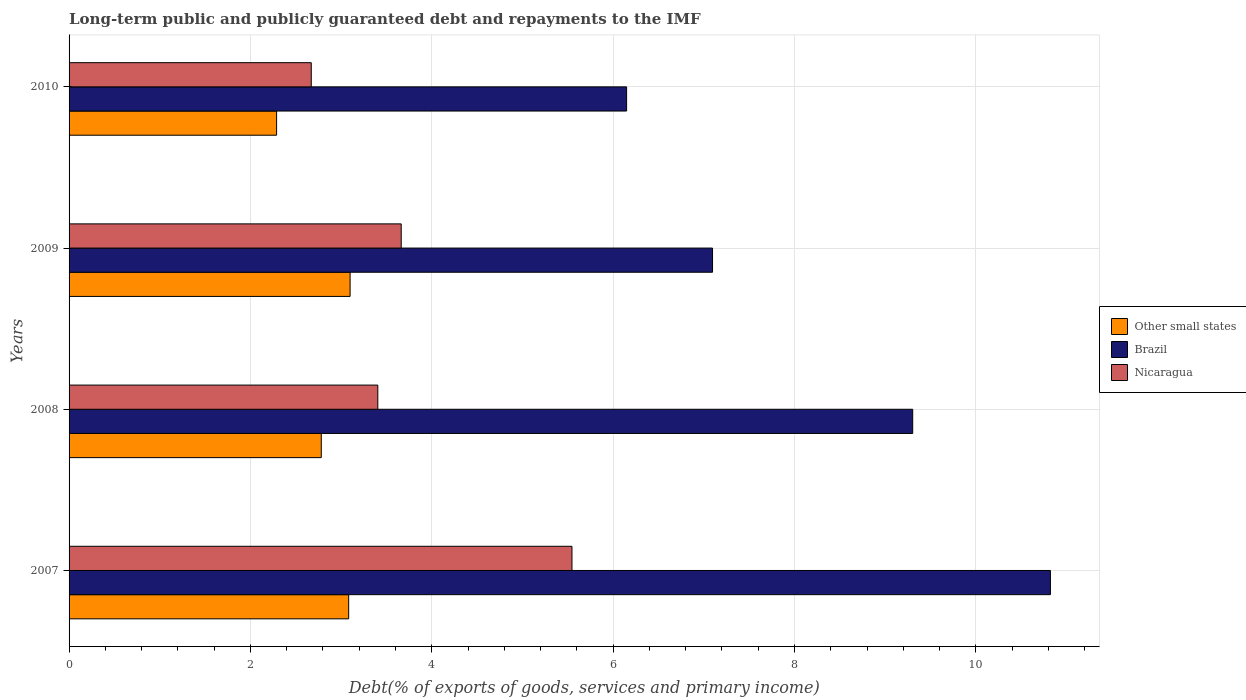How many different coloured bars are there?
Offer a very short reply. 3. How many groups of bars are there?
Offer a terse response. 4. Are the number of bars per tick equal to the number of legend labels?
Provide a succinct answer. Yes. How many bars are there on the 3rd tick from the top?
Keep it short and to the point. 3. How many bars are there on the 1st tick from the bottom?
Provide a short and direct response. 3. What is the label of the 4th group of bars from the top?
Provide a short and direct response. 2007. What is the debt and repayments in Nicaragua in 2010?
Provide a short and direct response. 2.67. Across all years, what is the maximum debt and repayments in Nicaragua?
Ensure brevity in your answer.  5.55. Across all years, what is the minimum debt and repayments in Nicaragua?
Offer a terse response. 2.67. In which year was the debt and repayments in Brazil minimum?
Your answer should be very brief. 2010. What is the total debt and repayments in Nicaragua in the graph?
Provide a short and direct response. 15.28. What is the difference between the debt and repayments in Brazil in 2007 and that in 2010?
Provide a succinct answer. 4.67. What is the difference between the debt and repayments in Nicaragua in 2010 and the debt and repayments in Brazil in 2008?
Make the answer very short. -6.63. What is the average debt and repayments in Other small states per year?
Provide a short and direct response. 2.81. In the year 2010, what is the difference between the debt and repayments in Other small states and debt and repayments in Brazil?
Your response must be concise. -3.86. In how many years, is the debt and repayments in Nicaragua greater than 5.2 %?
Ensure brevity in your answer.  1. What is the ratio of the debt and repayments in Other small states in 2007 to that in 2010?
Provide a short and direct response. 1.35. Is the debt and repayments in Nicaragua in 2008 less than that in 2010?
Provide a succinct answer. No. Is the difference between the debt and repayments in Other small states in 2009 and 2010 greater than the difference between the debt and repayments in Brazil in 2009 and 2010?
Make the answer very short. No. What is the difference between the highest and the second highest debt and repayments in Nicaragua?
Offer a terse response. 1.88. What is the difference between the highest and the lowest debt and repayments in Nicaragua?
Ensure brevity in your answer.  2.87. What does the 3rd bar from the top in 2007 represents?
Offer a terse response. Other small states. What does the 2nd bar from the bottom in 2010 represents?
Make the answer very short. Brazil. Is it the case that in every year, the sum of the debt and repayments in Other small states and debt and repayments in Nicaragua is greater than the debt and repayments in Brazil?
Your response must be concise. No. Are all the bars in the graph horizontal?
Your response must be concise. Yes. Does the graph contain any zero values?
Provide a short and direct response. No. Does the graph contain grids?
Your answer should be very brief. Yes. Where does the legend appear in the graph?
Keep it short and to the point. Center right. How many legend labels are there?
Ensure brevity in your answer.  3. What is the title of the graph?
Your response must be concise. Long-term public and publicly guaranteed debt and repayments to the IMF. Does "Burundi" appear as one of the legend labels in the graph?
Offer a very short reply. No. What is the label or title of the X-axis?
Offer a very short reply. Debt(% of exports of goods, services and primary income). What is the Debt(% of exports of goods, services and primary income) of Other small states in 2007?
Give a very brief answer. 3.08. What is the Debt(% of exports of goods, services and primary income) of Brazil in 2007?
Make the answer very short. 10.82. What is the Debt(% of exports of goods, services and primary income) in Nicaragua in 2007?
Your response must be concise. 5.55. What is the Debt(% of exports of goods, services and primary income) in Other small states in 2008?
Provide a succinct answer. 2.78. What is the Debt(% of exports of goods, services and primary income) of Brazil in 2008?
Offer a terse response. 9.3. What is the Debt(% of exports of goods, services and primary income) in Nicaragua in 2008?
Your answer should be very brief. 3.4. What is the Debt(% of exports of goods, services and primary income) of Other small states in 2009?
Make the answer very short. 3.1. What is the Debt(% of exports of goods, services and primary income) in Brazil in 2009?
Your answer should be compact. 7.1. What is the Debt(% of exports of goods, services and primary income) in Nicaragua in 2009?
Offer a very short reply. 3.66. What is the Debt(% of exports of goods, services and primary income) in Other small states in 2010?
Offer a very short reply. 2.29. What is the Debt(% of exports of goods, services and primary income) in Brazil in 2010?
Provide a short and direct response. 6.15. What is the Debt(% of exports of goods, services and primary income) in Nicaragua in 2010?
Provide a short and direct response. 2.67. Across all years, what is the maximum Debt(% of exports of goods, services and primary income) in Other small states?
Your response must be concise. 3.1. Across all years, what is the maximum Debt(% of exports of goods, services and primary income) of Brazil?
Ensure brevity in your answer.  10.82. Across all years, what is the maximum Debt(% of exports of goods, services and primary income) in Nicaragua?
Offer a terse response. 5.55. Across all years, what is the minimum Debt(% of exports of goods, services and primary income) in Other small states?
Ensure brevity in your answer.  2.29. Across all years, what is the minimum Debt(% of exports of goods, services and primary income) in Brazil?
Your response must be concise. 6.15. Across all years, what is the minimum Debt(% of exports of goods, services and primary income) in Nicaragua?
Offer a very short reply. 2.67. What is the total Debt(% of exports of goods, services and primary income) of Other small states in the graph?
Offer a terse response. 11.25. What is the total Debt(% of exports of goods, services and primary income) of Brazil in the graph?
Provide a short and direct response. 33.37. What is the total Debt(% of exports of goods, services and primary income) of Nicaragua in the graph?
Provide a short and direct response. 15.28. What is the difference between the Debt(% of exports of goods, services and primary income) in Other small states in 2007 and that in 2008?
Provide a short and direct response. 0.3. What is the difference between the Debt(% of exports of goods, services and primary income) of Brazil in 2007 and that in 2008?
Offer a terse response. 1.52. What is the difference between the Debt(% of exports of goods, services and primary income) of Nicaragua in 2007 and that in 2008?
Your answer should be very brief. 2.14. What is the difference between the Debt(% of exports of goods, services and primary income) in Other small states in 2007 and that in 2009?
Your answer should be compact. -0.02. What is the difference between the Debt(% of exports of goods, services and primary income) in Brazil in 2007 and that in 2009?
Your response must be concise. 3.73. What is the difference between the Debt(% of exports of goods, services and primary income) of Nicaragua in 2007 and that in 2009?
Your response must be concise. 1.88. What is the difference between the Debt(% of exports of goods, services and primary income) of Other small states in 2007 and that in 2010?
Your response must be concise. 0.79. What is the difference between the Debt(% of exports of goods, services and primary income) in Brazil in 2007 and that in 2010?
Your answer should be compact. 4.67. What is the difference between the Debt(% of exports of goods, services and primary income) of Nicaragua in 2007 and that in 2010?
Give a very brief answer. 2.87. What is the difference between the Debt(% of exports of goods, services and primary income) of Other small states in 2008 and that in 2009?
Your answer should be compact. -0.32. What is the difference between the Debt(% of exports of goods, services and primary income) of Brazil in 2008 and that in 2009?
Give a very brief answer. 2.21. What is the difference between the Debt(% of exports of goods, services and primary income) of Nicaragua in 2008 and that in 2009?
Provide a short and direct response. -0.26. What is the difference between the Debt(% of exports of goods, services and primary income) in Other small states in 2008 and that in 2010?
Provide a succinct answer. 0.49. What is the difference between the Debt(% of exports of goods, services and primary income) of Brazil in 2008 and that in 2010?
Give a very brief answer. 3.15. What is the difference between the Debt(% of exports of goods, services and primary income) in Nicaragua in 2008 and that in 2010?
Provide a succinct answer. 0.73. What is the difference between the Debt(% of exports of goods, services and primary income) in Other small states in 2009 and that in 2010?
Your answer should be very brief. 0.81. What is the difference between the Debt(% of exports of goods, services and primary income) of Brazil in 2009 and that in 2010?
Your response must be concise. 0.95. What is the difference between the Debt(% of exports of goods, services and primary income) of Other small states in 2007 and the Debt(% of exports of goods, services and primary income) of Brazil in 2008?
Offer a terse response. -6.22. What is the difference between the Debt(% of exports of goods, services and primary income) of Other small states in 2007 and the Debt(% of exports of goods, services and primary income) of Nicaragua in 2008?
Your answer should be compact. -0.32. What is the difference between the Debt(% of exports of goods, services and primary income) of Brazil in 2007 and the Debt(% of exports of goods, services and primary income) of Nicaragua in 2008?
Provide a short and direct response. 7.42. What is the difference between the Debt(% of exports of goods, services and primary income) in Other small states in 2007 and the Debt(% of exports of goods, services and primary income) in Brazil in 2009?
Provide a succinct answer. -4.01. What is the difference between the Debt(% of exports of goods, services and primary income) in Other small states in 2007 and the Debt(% of exports of goods, services and primary income) in Nicaragua in 2009?
Ensure brevity in your answer.  -0.58. What is the difference between the Debt(% of exports of goods, services and primary income) of Brazil in 2007 and the Debt(% of exports of goods, services and primary income) of Nicaragua in 2009?
Keep it short and to the point. 7.16. What is the difference between the Debt(% of exports of goods, services and primary income) in Other small states in 2007 and the Debt(% of exports of goods, services and primary income) in Brazil in 2010?
Ensure brevity in your answer.  -3.06. What is the difference between the Debt(% of exports of goods, services and primary income) in Other small states in 2007 and the Debt(% of exports of goods, services and primary income) in Nicaragua in 2010?
Keep it short and to the point. 0.41. What is the difference between the Debt(% of exports of goods, services and primary income) in Brazil in 2007 and the Debt(% of exports of goods, services and primary income) in Nicaragua in 2010?
Ensure brevity in your answer.  8.15. What is the difference between the Debt(% of exports of goods, services and primary income) of Other small states in 2008 and the Debt(% of exports of goods, services and primary income) of Brazil in 2009?
Keep it short and to the point. -4.31. What is the difference between the Debt(% of exports of goods, services and primary income) in Other small states in 2008 and the Debt(% of exports of goods, services and primary income) in Nicaragua in 2009?
Your response must be concise. -0.88. What is the difference between the Debt(% of exports of goods, services and primary income) of Brazil in 2008 and the Debt(% of exports of goods, services and primary income) of Nicaragua in 2009?
Provide a short and direct response. 5.64. What is the difference between the Debt(% of exports of goods, services and primary income) of Other small states in 2008 and the Debt(% of exports of goods, services and primary income) of Brazil in 2010?
Offer a very short reply. -3.37. What is the difference between the Debt(% of exports of goods, services and primary income) of Other small states in 2008 and the Debt(% of exports of goods, services and primary income) of Nicaragua in 2010?
Provide a short and direct response. 0.11. What is the difference between the Debt(% of exports of goods, services and primary income) of Brazil in 2008 and the Debt(% of exports of goods, services and primary income) of Nicaragua in 2010?
Ensure brevity in your answer.  6.63. What is the difference between the Debt(% of exports of goods, services and primary income) in Other small states in 2009 and the Debt(% of exports of goods, services and primary income) in Brazil in 2010?
Provide a short and direct response. -3.05. What is the difference between the Debt(% of exports of goods, services and primary income) of Other small states in 2009 and the Debt(% of exports of goods, services and primary income) of Nicaragua in 2010?
Your answer should be very brief. 0.43. What is the difference between the Debt(% of exports of goods, services and primary income) of Brazil in 2009 and the Debt(% of exports of goods, services and primary income) of Nicaragua in 2010?
Your answer should be very brief. 4.42. What is the average Debt(% of exports of goods, services and primary income) of Other small states per year?
Your response must be concise. 2.81. What is the average Debt(% of exports of goods, services and primary income) in Brazil per year?
Make the answer very short. 8.34. What is the average Debt(% of exports of goods, services and primary income) of Nicaragua per year?
Your answer should be very brief. 3.82. In the year 2007, what is the difference between the Debt(% of exports of goods, services and primary income) of Other small states and Debt(% of exports of goods, services and primary income) of Brazil?
Offer a very short reply. -7.74. In the year 2007, what is the difference between the Debt(% of exports of goods, services and primary income) in Other small states and Debt(% of exports of goods, services and primary income) in Nicaragua?
Offer a very short reply. -2.46. In the year 2007, what is the difference between the Debt(% of exports of goods, services and primary income) in Brazil and Debt(% of exports of goods, services and primary income) in Nicaragua?
Make the answer very short. 5.28. In the year 2008, what is the difference between the Debt(% of exports of goods, services and primary income) of Other small states and Debt(% of exports of goods, services and primary income) of Brazil?
Provide a short and direct response. -6.52. In the year 2008, what is the difference between the Debt(% of exports of goods, services and primary income) in Other small states and Debt(% of exports of goods, services and primary income) in Nicaragua?
Provide a succinct answer. -0.62. In the year 2008, what is the difference between the Debt(% of exports of goods, services and primary income) in Brazil and Debt(% of exports of goods, services and primary income) in Nicaragua?
Your response must be concise. 5.9. In the year 2009, what is the difference between the Debt(% of exports of goods, services and primary income) in Other small states and Debt(% of exports of goods, services and primary income) in Brazil?
Keep it short and to the point. -4. In the year 2009, what is the difference between the Debt(% of exports of goods, services and primary income) of Other small states and Debt(% of exports of goods, services and primary income) of Nicaragua?
Ensure brevity in your answer.  -0.56. In the year 2009, what is the difference between the Debt(% of exports of goods, services and primary income) in Brazil and Debt(% of exports of goods, services and primary income) in Nicaragua?
Provide a short and direct response. 3.43. In the year 2010, what is the difference between the Debt(% of exports of goods, services and primary income) of Other small states and Debt(% of exports of goods, services and primary income) of Brazil?
Your answer should be very brief. -3.86. In the year 2010, what is the difference between the Debt(% of exports of goods, services and primary income) of Other small states and Debt(% of exports of goods, services and primary income) of Nicaragua?
Keep it short and to the point. -0.38. In the year 2010, what is the difference between the Debt(% of exports of goods, services and primary income) in Brazil and Debt(% of exports of goods, services and primary income) in Nicaragua?
Keep it short and to the point. 3.48. What is the ratio of the Debt(% of exports of goods, services and primary income) in Other small states in 2007 to that in 2008?
Provide a short and direct response. 1.11. What is the ratio of the Debt(% of exports of goods, services and primary income) of Brazil in 2007 to that in 2008?
Keep it short and to the point. 1.16. What is the ratio of the Debt(% of exports of goods, services and primary income) in Nicaragua in 2007 to that in 2008?
Provide a succinct answer. 1.63. What is the ratio of the Debt(% of exports of goods, services and primary income) in Brazil in 2007 to that in 2009?
Offer a very short reply. 1.53. What is the ratio of the Debt(% of exports of goods, services and primary income) in Nicaragua in 2007 to that in 2009?
Your answer should be compact. 1.51. What is the ratio of the Debt(% of exports of goods, services and primary income) in Other small states in 2007 to that in 2010?
Offer a terse response. 1.35. What is the ratio of the Debt(% of exports of goods, services and primary income) in Brazil in 2007 to that in 2010?
Your answer should be compact. 1.76. What is the ratio of the Debt(% of exports of goods, services and primary income) of Nicaragua in 2007 to that in 2010?
Offer a very short reply. 2.08. What is the ratio of the Debt(% of exports of goods, services and primary income) in Other small states in 2008 to that in 2009?
Offer a very short reply. 0.9. What is the ratio of the Debt(% of exports of goods, services and primary income) of Brazil in 2008 to that in 2009?
Your answer should be very brief. 1.31. What is the ratio of the Debt(% of exports of goods, services and primary income) in Nicaragua in 2008 to that in 2009?
Offer a very short reply. 0.93. What is the ratio of the Debt(% of exports of goods, services and primary income) of Other small states in 2008 to that in 2010?
Provide a succinct answer. 1.22. What is the ratio of the Debt(% of exports of goods, services and primary income) in Brazil in 2008 to that in 2010?
Offer a terse response. 1.51. What is the ratio of the Debt(% of exports of goods, services and primary income) of Nicaragua in 2008 to that in 2010?
Your answer should be compact. 1.27. What is the ratio of the Debt(% of exports of goods, services and primary income) of Other small states in 2009 to that in 2010?
Your response must be concise. 1.35. What is the ratio of the Debt(% of exports of goods, services and primary income) of Brazil in 2009 to that in 2010?
Your response must be concise. 1.15. What is the ratio of the Debt(% of exports of goods, services and primary income) in Nicaragua in 2009 to that in 2010?
Offer a terse response. 1.37. What is the difference between the highest and the second highest Debt(% of exports of goods, services and primary income) in Other small states?
Make the answer very short. 0.02. What is the difference between the highest and the second highest Debt(% of exports of goods, services and primary income) of Brazil?
Your answer should be compact. 1.52. What is the difference between the highest and the second highest Debt(% of exports of goods, services and primary income) in Nicaragua?
Your answer should be compact. 1.88. What is the difference between the highest and the lowest Debt(% of exports of goods, services and primary income) of Other small states?
Offer a terse response. 0.81. What is the difference between the highest and the lowest Debt(% of exports of goods, services and primary income) of Brazil?
Keep it short and to the point. 4.67. What is the difference between the highest and the lowest Debt(% of exports of goods, services and primary income) of Nicaragua?
Your answer should be compact. 2.87. 